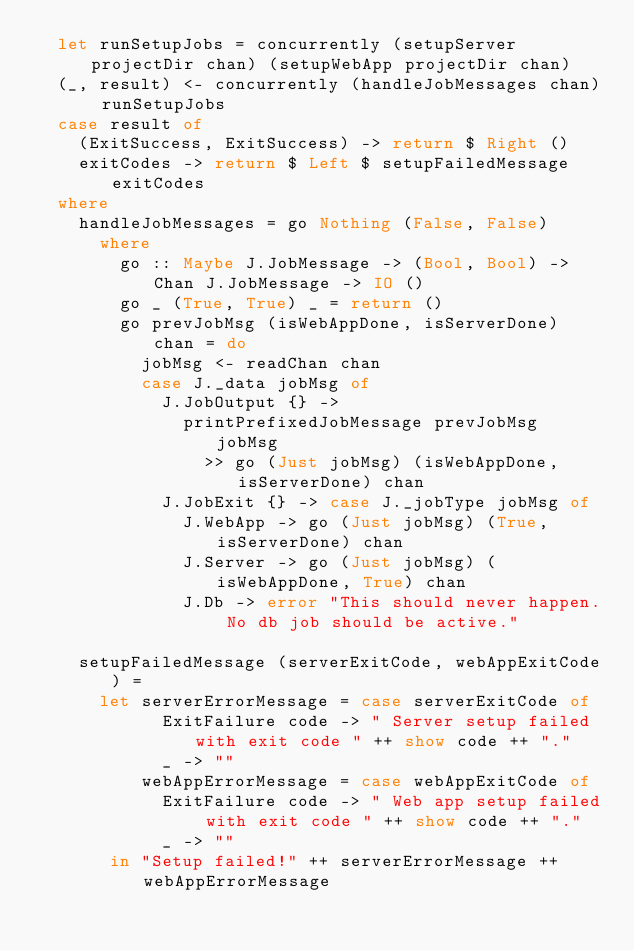Convert code to text. <code><loc_0><loc_0><loc_500><loc_500><_Haskell_>  let runSetupJobs = concurrently (setupServer projectDir chan) (setupWebApp projectDir chan)
  (_, result) <- concurrently (handleJobMessages chan) runSetupJobs
  case result of
    (ExitSuccess, ExitSuccess) -> return $ Right ()
    exitCodes -> return $ Left $ setupFailedMessage exitCodes
  where
    handleJobMessages = go Nothing (False, False)
      where
        go :: Maybe J.JobMessage -> (Bool, Bool) -> Chan J.JobMessage -> IO ()
        go _ (True, True) _ = return ()
        go prevJobMsg (isWebAppDone, isServerDone) chan = do
          jobMsg <- readChan chan
          case J._data jobMsg of
            J.JobOutput {} ->
              printPrefixedJobMessage prevJobMsg jobMsg
                >> go (Just jobMsg) (isWebAppDone, isServerDone) chan
            J.JobExit {} -> case J._jobType jobMsg of
              J.WebApp -> go (Just jobMsg) (True, isServerDone) chan
              J.Server -> go (Just jobMsg) (isWebAppDone, True) chan
              J.Db -> error "This should never happen. No db job should be active."

    setupFailedMessage (serverExitCode, webAppExitCode) =
      let serverErrorMessage = case serverExitCode of
            ExitFailure code -> " Server setup failed with exit code " ++ show code ++ "."
            _ -> ""
          webAppErrorMessage = case webAppExitCode of
            ExitFailure code -> " Web app setup failed with exit code " ++ show code ++ "."
            _ -> ""
       in "Setup failed!" ++ serverErrorMessage ++ webAppErrorMessage
</code> 